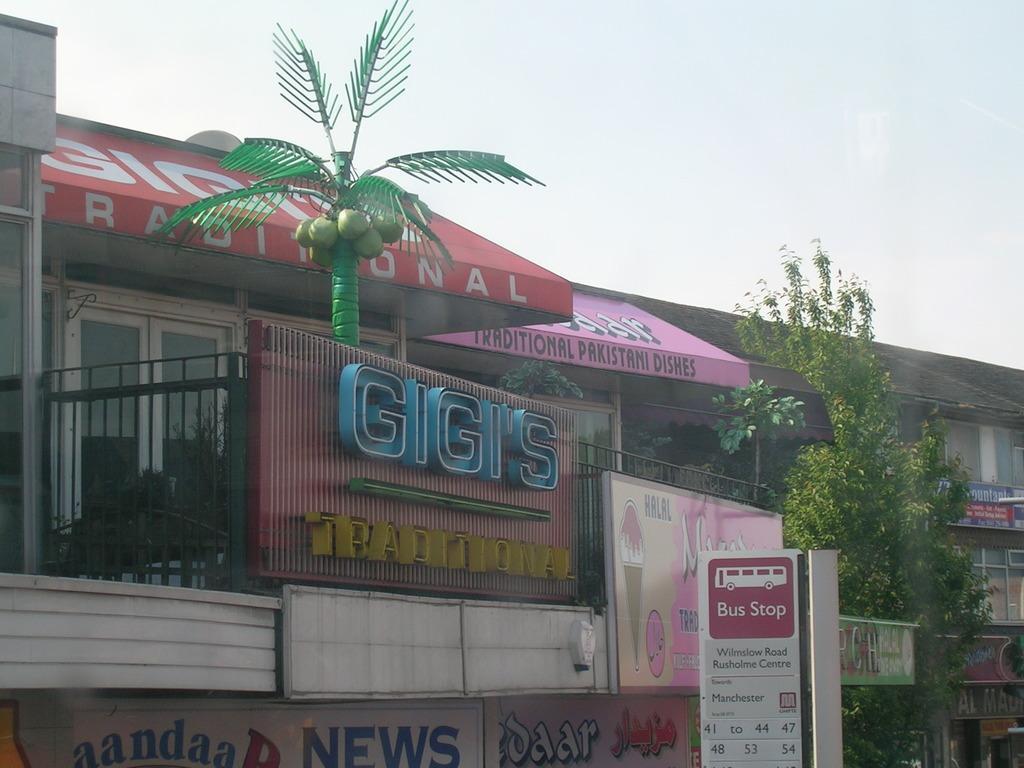Describe this image in one or two sentences. In this image there are buildings, text boards, hoardings and some information boards are present. Image also consists of trees. At the top there is sky. There is also an artificial coconut tree. 